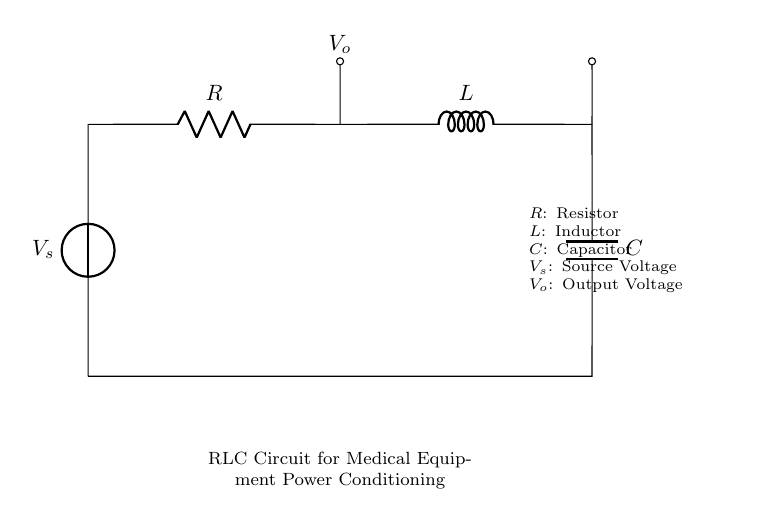What is the source voltage in this circuit? The source voltage, denoted as V_s, is the driving voltage for the entire circuit. In the visual information provided, it is labeled as V_s at the left side of the circuit diagram.
Answer: V_s What component is in series with the resistor? The circuit shows that the inductor, represented by L, is directly next in line after the resistor, thus making it the component in series with the resistor.
Answer: L What is the purpose of the capacitor in this circuit? The capacitor is used for filtering and smoothing out the voltage output, preventing sudden spikes and ensuring stable voltage delivery to the load. This function is typical for power conditioning in medical equipment.
Answer: Filtering Which component affects the rate of current change in the circuit? The inductor, labeled L, has the property to resist changes in current. This is due to its ability to store energy in a magnetic field, hence it affects the rate of current change significantly in the circuit.
Answer: L What would increase the overall impedance of the circuit? Increasing the resistance value R or adding more inductance would increase the overall impedance in this RLC circuit, as impedance in RLC circuits is a function of resistance, inductance, and frequency.
Answer: Resistance or Inductance What type of circuit is represented in the diagram? The diagram represents an RLC circuit which combines resistive, inductive, and capacitive components for power conditioning applications typically needed in medical equipment.
Answer: RLC circuit What would happen if the capacitor is removed from the circuit? Removing the capacitor would eliminate its filtering effect, leading to potential voltage fluctuations and instability at the output, which could negatively affect connected medical devices.
Answer: Voltage fluctuations 